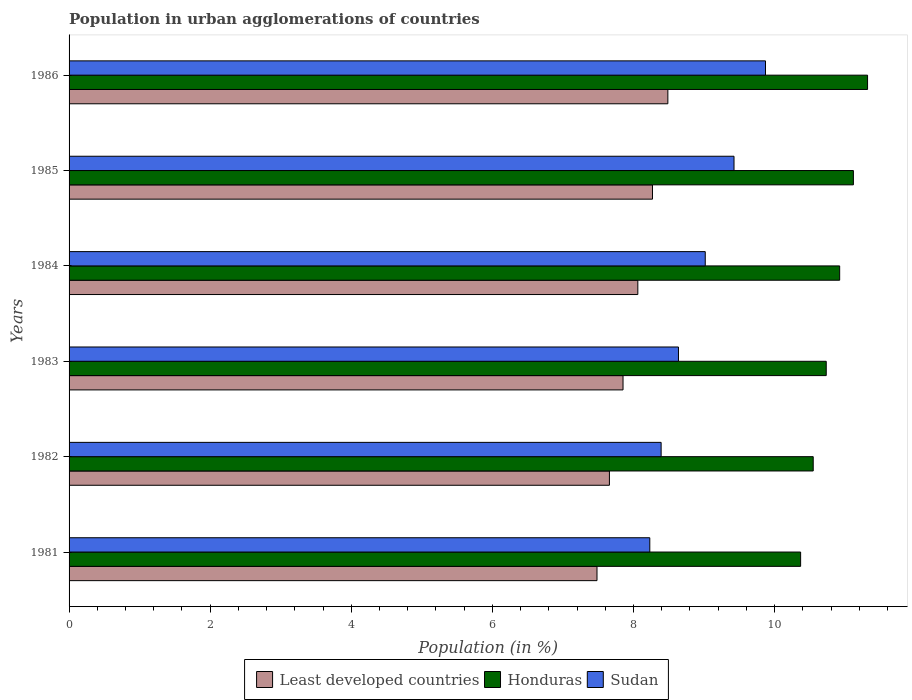How many groups of bars are there?
Offer a very short reply. 6. How many bars are there on the 5th tick from the top?
Provide a succinct answer. 3. In how many cases, is the number of bars for a given year not equal to the number of legend labels?
Your response must be concise. 0. What is the percentage of population in urban agglomerations in Least developed countries in 1982?
Your response must be concise. 7.66. Across all years, what is the maximum percentage of population in urban agglomerations in Honduras?
Ensure brevity in your answer.  11.32. Across all years, what is the minimum percentage of population in urban agglomerations in Sudan?
Your answer should be compact. 8.23. In which year was the percentage of population in urban agglomerations in Sudan maximum?
Give a very brief answer. 1986. In which year was the percentage of population in urban agglomerations in Least developed countries minimum?
Offer a very short reply. 1981. What is the total percentage of population in urban agglomerations in Honduras in the graph?
Keep it short and to the point. 65.01. What is the difference between the percentage of population in urban agglomerations in Least developed countries in 1982 and that in 1986?
Offer a very short reply. -0.83. What is the difference between the percentage of population in urban agglomerations in Sudan in 1981 and the percentage of population in urban agglomerations in Honduras in 1986?
Provide a short and direct response. -3.09. What is the average percentage of population in urban agglomerations in Least developed countries per year?
Make the answer very short. 7.97. In the year 1986, what is the difference between the percentage of population in urban agglomerations in Sudan and percentage of population in urban agglomerations in Honduras?
Keep it short and to the point. -1.45. In how many years, is the percentage of population in urban agglomerations in Least developed countries greater than 5.2 %?
Offer a very short reply. 6. What is the ratio of the percentage of population in urban agglomerations in Honduras in 1983 to that in 1984?
Keep it short and to the point. 0.98. Is the difference between the percentage of population in urban agglomerations in Sudan in 1985 and 1986 greater than the difference between the percentage of population in urban agglomerations in Honduras in 1985 and 1986?
Give a very brief answer. No. What is the difference between the highest and the second highest percentage of population in urban agglomerations in Honduras?
Provide a succinct answer. 0.2. What is the difference between the highest and the lowest percentage of population in urban agglomerations in Sudan?
Your answer should be compact. 1.64. In how many years, is the percentage of population in urban agglomerations in Honduras greater than the average percentage of population in urban agglomerations in Honduras taken over all years?
Provide a short and direct response. 3. What does the 1st bar from the top in 1982 represents?
Offer a very short reply. Sudan. What does the 3rd bar from the bottom in 1982 represents?
Keep it short and to the point. Sudan. Is it the case that in every year, the sum of the percentage of population in urban agglomerations in Sudan and percentage of population in urban agglomerations in Least developed countries is greater than the percentage of population in urban agglomerations in Honduras?
Offer a terse response. Yes. How many bars are there?
Ensure brevity in your answer.  18. Are the values on the major ticks of X-axis written in scientific E-notation?
Offer a terse response. No. Does the graph contain any zero values?
Give a very brief answer. No. Does the graph contain grids?
Your answer should be very brief. No. Where does the legend appear in the graph?
Your answer should be very brief. Bottom center. How are the legend labels stacked?
Keep it short and to the point. Horizontal. What is the title of the graph?
Your answer should be very brief. Population in urban agglomerations of countries. Does "Micronesia" appear as one of the legend labels in the graph?
Your response must be concise. No. What is the Population (in %) of Least developed countries in 1981?
Provide a succinct answer. 7.48. What is the Population (in %) in Honduras in 1981?
Offer a terse response. 10.37. What is the Population (in %) of Sudan in 1981?
Offer a very short reply. 8.23. What is the Population (in %) of Least developed countries in 1982?
Ensure brevity in your answer.  7.66. What is the Population (in %) of Honduras in 1982?
Your answer should be very brief. 10.55. What is the Population (in %) of Sudan in 1982?
Your answer should be very brief. 8.39. What is the Population (in %) of Least developed countries in 1983?
Ensure brevity in your answer.  7.85. What is the Population (in %) of Honduras in 1983?
Give a very brief answer. 10.73. What is the Population (in %) in Sudan in 1983?
Ensure brevity in your answer.  8.64. What is the Population (in %) of Least developed countries in 1984?
Your response must be concise. 8.06. What is the Population (in %) in Honduras in 1984?
Provide a short and direct response. 10.92. What is the Population (in %) in Sudan in 1984?
Ensure brevity in your answer.  9.02. What is the Population (in %) of Least developed countries in 1985?
Provide a succinct answer. 8.27. What is the Population (in %) of Honduras in 1985?
Make the answer very short. 11.12. What is the Population (in %) of Sudan in 1985?
Give a very brief answer. 9.42. What is the Population (in %) in Least developed countries in 1986?
Offer a very short reply. 8.49. What is the Population (in %) in Honduras in 1986?
Provide a succinct answer. 11.32. What is the Population (in %) in Sudan in 1986?
Make the answer very short. 9.87. Across all years, what is the maximum Population (in %) in Least developed countries?
Give a very brief answer. 8.49. Across all years, what is the maximum Population (in %) of Honduras?
Give a very brief answer. 11.32. Across all years, what is the maximum Population (in %) in Sudan?
Provide a succinct answer. 9.87. Across all years, what is the minimum Population (in %) in Least developed countries?
Your answer should be compact. 7.48. Across all years, what is the minimum Population (in %) of Honduras?
Provide a succinct answer. 10.37. Across all years, what is the minimum Population (in %) in Sudan?
Keep it short and to the point. 8.23. What is the total Population (in %) of Least developed countries in the graph?
Ensure brevity in your answer.  47.81. What is the total Population (in %) in Honduras in the graph?
Keep it short and to the point. 65.01. What is the total Population (in %) in Sudan in the graph?
Make the answer very short. 53.57. What is the difference between the Population (in %) in Least developed countries in 1981 and that in 1982?
Give a very brief answer. -0.18. What is the difference between the Population (in %) of Honduras in 1981 and that in 1982?
Your answer should be compact. -0.18. What is the difference between the Population (in %) in Sudan in 1981 and that in 1982?
Your response must be concise. -0.16. What is the difference between the Population (in %) in Least developed countries in 1981 and that in 1983?
Provide a short and direct response. -0.37. What is the difference between the Population (in %) in Honduras in 1981 and that in 1983?
Ensure brevity in your answer.  -0.36. What is the difference between the Population (in %) in Sudan in 1981 and that in 1983?
Ensure brevity in your answer.  -0.41. What is the difference between the Population (in %) in Least developed countries in 1981 and that in 1984?
Ensure brevity in your answer.  -0.58. What is the difference between the Population (in %) of Honduras in 1981 and that in 1984?
Provide a short and direct response. -0.55. What is the difference between the Population (in %) of Sudan in 1981 and that in 1984?
Ensure brevity in your answer.  -0.79. What is the difference between the Population (in %) in Least developed countries in 1981 and that in 1985?
Provide a succinct answer. -0.79. What is the difference between the Population (in %) of Honduras in 1981 and that in 1985?
Provide a short and direct response. -0.75. What is the difference between the Population (in %) of Sudan in 1981 and that in 1985?
Offer a terse response. -1.19. What is the difference between the Population (in %) in Least developed countries in 1981 and that in 1986?
Offer a terse response. -1. What is the difference between the Population (in %) in Honduras in 1981 and that in 1986?
Make the answer very short. -0.95. What is the difference between the Population (in %) of Sudan in 1981 and that in 1986?
Make the answer very short. -1.64. What is the difference between the Population (in %) of Least developed countries in 1982 and that in 1983?
Your answer should be compact. -0.19. What is the difference between the Population (in %) in Honduras in 1982 and that in 1983?
Give a very brief answer. -0.18. What is the difference between the Population (in %) in Sudan in 1982 and that in 1983?
Make the answer very short. -0.25. What is the difference between the Population (in %) of Least developed countries in 1982 and that in 1984?
Provide a succinct answer. -0.4. What is the difference between the Population (in %) in Honduras in 1982 and that in 1984?
Keep it short and to the point. -0.37. What is the difference between the Population (in %) in Sudan in 1982 and that in 1984?
Offer a terse response. -0.63. What is the difference between the Population (in %) of Least developed countries in 1982 and that in 1985?
Your answer should be compact. -0.61. What is the difference between the Population (in %) in Honduras in 1982 and that in 1985?
Make the answer very short. -0.57. What is the difference between the Population (in %) of Sudan in 1982 and that in 1985?
Provide a succinct answer. -1.03. What is the difference between the Population (in %) of Least developed countries in 1982 and that in 1986?
Provide a short and direct response. -0.83. What is the difference between the Population (in %) of Honduras in 1982 and that in 1986?
Make the answer very short. -0.77. What is the difference between the Population (in %) of Sudan in 1982 and that in 1986?
Ensure brevity in your answer.  -1.48. What is the difference between the Population (in %) in Least developed countries in 1983 and that in 1984?
Offer a terse response. -0.21. What is the difference between the Population (in %) of Honduras in 1983 and that in 1984?
Your response must be concise. -0.19. What is the difference between the Population (in %) of Sudan in 1983 and that in 1984?
Give a very brief answer. -0.38. What is the difference between the Population (in %) of Least developed countries in 1983 and that in 1985?
Give a very brief answer. -0.42. What is the difference between the Population (in %) in Honduras in 1983 and that in 1985?
Ensure brevity in your answer.  -0.38. What is the difference between the Population (in %) of Sudan in 1983 and that in 1985?
Ensure brevity in your answer.  -0.79. What is the difference between the Population (in %) in Least developed countries in 1983 and that in 1986?
Provide a short and direct response. -0.64. What is the difference between the Population (in %) of Honduras in 1983 and that in 1986?
Provide a short and direct response. -0.59. What is the difference between the Population (in %) in Sudan in 1983 and that in 1986?
Your answer should be compact. -1.23. What is the difference between the Population (in %) of Least developed countries in 1984 and that in 1985?
Your answer should be very brief. -0.21. What is the difference between the Population (in %) in Honduras in 1984 and that in 1985?
Give a very brief answer. -0.19. What is the difference between the Population (in %) in Sudan in 1984 and that in 1985?
Provide a succinct answer. -0.41. What is the difference between the Population (in %) of Least developed countries in 1984 and that in 1986?
Your answer should be very brief. -0.43. What is the difference between the Population (in %) of Honduras in 1984 and that in 1986?
Make the answer very short. -0.4. What is the difference between the Population (in %) of Sudan in 1984 and that in 1986?
Offer a terse response. -0.85. What is the difference between the Population (in %) of Least developed countries in 1985 and that in 1986?
Ensure brevity in your answer.  -0.22. What is the difference between the Population (in %) in Honduras in 1985 and that in 1986?
Offer a very short reply. -0.2. What is the difference between the Population (in %) in Sudan in 1985 and that in 1986?
Make the answer very short. -0.45. What is the difference between the Population (in %) in Least developed countries in 1981 and the Population (in %) in Honduras in 1982?
Provide a short and direct response. -3.06. What is the difference between the Population (in %) of Least developed countries in 1981 and the Population (in %) of Sudan in 1982?
Your response must be concise. -0.91. What is the difference between the Population (in %) in Honduras in 1981 and the Population (in %) in Sudan in 1982?
Give a very brief answer. 1.98. What is the difference between the Population (in %) of Least developed countries in 1981 and the Population (in %) of Honduras in 1983?
Provide a short and direct response. -3.25. What is the difference between the Population (in %) of Least developed countries in 1981 and the Population (in %) of Sudan in 1983?
Provide a succinct answer. -1.15. What is the difference between the Population (in %) in Honduras in 1981 and the Population (in %) in Sudan in 1983?
Give a very brief answer. 1.73. What is the difference between the Population (in %) of Least developed countries in 1981 and the Population (in %) of Honduras in 1984?
Your answer should be compact. -3.44. What is the difference between the Population (in %) in Least developed countries in 1981 and the Population (in %) in Sudan in 1984?
Make the answer very short. -1.53. What is the difference between the Population (in %) of Honduras in 1981 and the Population (in %) of Sudan in 1984?
Ensure brevity in your answer.  1.35. What is the difference between the Population (in %) in Least developed countries in 1981 and the Population (in %) in Honduras in 1985?
Ensure brevity in your answer.  -3.63. What is the difference between the Population (in %) of Least developed countries in 1981 and the Population (in %) of Sudan in 1985?
Offer a very short reply. -1.94. What is the difference between the Population (in %) of Honduras in 1981 and the Population (in %) of Sudan in 1985?
Provide a short and direct response. 0.94. What is the difference between the Population (in %) in Least developed countries in 1981 and the Population (in %) in Honduras in 1986?
Provide a short and direct response. -3.84. What is the difference between the Population (in %) in Least developed countries in 1981 and the Population (in %) in Sudan in 1986?
Provide a short and direct response. -2.39. What is the difference between the Population (in %) in Honduras in 1981 and the Population (in %) in Sudan in 1986?
Make the answer very short. 0.5. What is the difference between the Population (in %) in Least developed countries in 1982 and the Population (in %) in Honduras in 1983?
Keep it short and to the point. -3.07. What is the difference between the Population (in %) in Least developed countries in 1982 and the Population (in %) in Sudan in 1983?
Keep it short and to the point. -0.98. What is the difference between the Population (in %) of Honduras in 1982 and the Population (in %) of Sudan in 1983?
Provide a short and direct response. 1.91. What is the difference between the Population (in %) in Least developed countries in 1982 and the Population (in %) in Honduras in 1984?
Keep it short and to the point. -3.26. What is the difference between the Population (in %) in Least developed countries in 1982 and the Population (in %) in Sudan in 1984?
Your answer should be very brief. -1.36. What is the difference between the Population (in %) of Honduras in 1982 and the Population (in %) of Sudan in 1984?
Provide a succinct answer. 1.53. What is the difference between the Population (in %) in Least developed countries in 1982 and the Population (in %) in Honduras in 1985?
Your answer should be very brief. -3.46. What is the difference between the Population (in %) in Least developed countries in 1982 and the Population (in %) in Sudan in 1985?
Offer a terse response. -1.77. What is the difference between the Population (in %) in Honduras in 1982 and the Population (in %) in Sudan in 1985?
Your answer should be very brief. 1.12. What is the difference between the Population (in %) of Least developed countries in 1982 and the Population (in %) of Honduras in 1986?
Provide a succinct answer. -3.66. What is the difference between the Population (in %) in Least developed countries in 1982 and the Population (in %) in Sudan in 1986?
Keep it short and to the point. -2.21. What is the difference between the Population (in %) in Honduras in 1982 and the Population (in %) in Sudan in 1986?
Ensure brevity in your answer.  0.68. What is the difference between the Population (in %) in Least developed countries in 1983 and the Population (in %) in Honduras in 1984?
Keep it short and to the point. -3.07. What is the difference between the Population (in %) of Least developed countries in 1983 and the Population (in %) of Sudan in 1984?
Your response must be concise. -1.17. What is the difference between the Population (in %) in Honduras in 1983 and the Population (in %) in Sudan in 1984?
Make the answer very short. 1.71. What is the difference between the Population (in %) in Least developed countries in 1983 and the Population (in %) in Honduras in 1985?
Offer a very short reply. -3.27. What is the difference between the Population (in %) of Least developed countries in 1983 and the Population (in %) of Sudan in 1985?
Give a very brief answer. -1.57. What is the difference between the Population (in %) in Honduras in 1983 and the Population (in %) in Sudan in 1985?
Provide a succinct answer. 1.31. What is the difference between the Population (in %) of Least developed countries in 1983 and the Population (in %) of Honduras in 1986?
Your answer should be compact. -3.47. What is the difference between the Population (in %) of Least developed countries in 1983 and the Population (in %) of Sudan in 1986?
Your response must be concise. -2.02. What is the difference between the Population (in %) in Honduras in 1983 and the Population (in %) in Sudan in 1986?
Keep it short and to the point. 0.86. What is the difference between the Population (in %) of Least developed countries in 1984 and the Population (in %) of Honduras in 1985?
Provide a succinct answer. -3.06. What is the difference between the Population (in %) of Least developed countries in 1984 and the Population (in %) of Sudan in 1985?
Make the answer very short. -1.36. What is the difference between the Population (in %) of Honduras in 1984 and the Population (in %) of Sudan in 1985?
Ensure brevity in your answer.  1.5. What is the difference between the Population (in %) of Least developed countries in 1984 and the Population (in %) of Honduras in 1986?
Give a very brief answer. -3.26. What is the difference between the Population (in %) of Least developed countries in 1984 and the Population (in %) of Sudan in 1986?
Ensure brevity in your answer.  -1.81. What is the difference between the Population (in %) of Honduras in 1984 and the Population (in %) of Sudan in 1986?
Your answer should be compact. 1.05. What is the difference between the Population (in %) in Least developed countries in 1985 and the Population (in %) in Honduras in 1986?
Your response must be concise. -3.05. What is the difference between the Population (in %) in Least developed countries in 1985 and the Population (in %) in Sudan in 1986?
Your answer should be very brief. -1.6. What is the difference between the Population (in %) of Honduras in 1985 and the Population (in %) of Sudan in 1986?
Provide a short and direct response. 1.25. What is the average Population (in %) of Least developed countries per year?
Your answer should be very brief. 7.97. What is the average Population (in %) of Honduras per year?
Offer a terse response. 10.83. What is the average Population (in %) of Sudan per year?
Provide a short and direct response. 8.93. In the year 1981, what is the difference between the Population (in %) in Least developed countries and Population (in %) in Honduras?
Provide a succinct answer. -2.89. In the year 1981, what is the difference between the Population (in %) of Least developed countries and Population (in %) of Sudan?
Make the answer very short. -0.75. In the year 1981, what is the difference between the Population (in %) of Honduras and Population (in %) of Sudan?
Make the answer very short. 2.14. In the year 1982, what is the difference between the Population (in %) in Least developed countries and Population (in %) in Honduras?
Offer a terse response. -2.89. In the year 1982, what is the difference between the Population (in %) of Least developed countries and Population (in %) of Sudan?
Offer a terse response. -0.73. In the year 1982, what is the difference between the Population (in %) of Honduras and Population (in %) of Sudan?
Provide a short and direct response. 2.16. In the year 1983, what is the difference between the Population (in %) in Least developed countries and Population (in %) in Honduras?
Ensure brevity in your answer.  -2.88. In the year 1983, what is the difference between the Population (in %) of Least developed countries and Population (in %) of Sudan?
Your answer should be compact. -0.79. In the year 1983, what is the difference between the Population (in %) of Honduras and Population (in %) of Sudan?
Make the answer very short. 2.09. In the year 1984, what is the difference between the Population (in %) of Least developed countries and Population (in %) of Honduras?
Give a very brief answer. -2.86. In the year 1984, what is the difference between the Population (in %) in Least developed countries and Population (in %) in Sudan?
Provide a short and direct response. -0.96. In the year 1984, what is the difference between the Population (in %) of Honduras and Population (in %) of Sudan?
Ensure brevity in your answer.  1.91. In the year 1985, what is the difference between the Population (in %) of Least developed countries and Population (in %) of Honduras?
Give a very brief answer. -2.85. In the year 1985, what is the difference between the Population (in %) in Least developed countries and Population (in %) in Sudan?
Give a very brief answer. -1.16. In the year 1985, what is the difference between the Population (in %) of Honduras and Population (in %) of Sudan?
Ensure brevity in your answer.  1.69. In the year 1986, what is the difference between the Population (in %) of Least developed countries and Population (in %) of Honduras?
Offer a terse response. -2.83. In the year 1986, what is the difference between the Population (in %) of Least developed countries and Population (in %) of Sudan?
Provide a short and direct response. -1.38. In the year 1986, what is the difference between the Population (in %) of Honduras and Population (in %) of Sudan?
Your answer should be very brief. 1.45. What is the ratio of the Population (in %) of Honduras in 1981 to that in 1982?
Ensure brevity in your answer.  0.98. What is the ratio of the Population (in %) of Sudan in 1981 to that in 1982?
Provide a succinct answer. 0.98. What is the ratio of the Population (in %) in Least developed countries in 1981 to that in 1983?
Your answer should be compact. 0.95. What is the ratio of the Population (in %) of Honduras in 1981 to that in 1983?
Give a very brief answer. 0.97. What is the ratio of the Population (in %) in Sudan in 1981 to that in 1983?
Your answer should be compact. 0.95. What is the ratio of the Population (in %) in Least developed countries in 1981 to that in 1984?
Your answer should be very brief. 0.93. What is the ratio of the Population (in %) of Honduras in 1981 to that in 1984?
Provide a succinct answer. 0.95. What is the ratio of the Population (in %) of Sudan in 1981 to that in 1984?
Offer a terse response. 0.91. What is the ratio of the Population (in %) of Least developed countries in 1981 to that in 1985?
Give a very brief answer. 0.9. What is the ratio of the Population (in %) of Honduras in 1981 to that in 1985?
Ensure brevity in your answer.  0.93. What is the ratio of the Population (in %) of Sudan in 1981 to that in 1985?
Your response must be concise. 0.87. What is the ratio of the Population (in %) in Least developed countries in 1981 to that in 1986?
Ensure brevity in your answer.  0.88. What is the ratio of the Population (in %) of Honduras in 1981 to that in 1986?
Offer a very short reply. 0.92. What is the ratio of the Population (in %) of Sudan in 1981 to that in 1986?
Offer a very short reply. 0.83. What is the ratio of the Population (in %) of Least developed countries in 1982 to that in 1983?
Keep it short and to the point. 0.98. What is the ratio of the Population (in %) of Honduras in 1982 to that in 1983?
Your answer should be compact. 0.98. What is the ratio of the Population (in %) of Sudan in 1982 to that in 1983?
Ensure brevity in your answer.  0.97. What is the ratio of the Population (in %) in Least developed countries in 1982 to that in 1984?
Offer a very short reply. 0.95. What is the ratio of the Population (in %) in Honduras in 1982 to that in 1984?
Your response must be concise. 0.97. What is the ratio of the Population (in %) of Sudan in 1982 to that in 1984?
Your answer should be compact. 0.93. What is the ratio of the Population (in %) in Least developed countries in 1982 to that in 1985?
Provide a succinct answer. 0.93. What is the ratio of the Population (in %) of Honduras in 1982 to that in 1985?
Make the answer very short. 0.95. What is the ratio of the Population (in %) in Sudan in 1982 to that in 1985?
Make the answer very short. 0.89. What is the ratio of the Population (in %) of Least developed countries in 1982 to that in 1986?
Provide a short and direct response. 0.9. What is the ratio of the Population (in %) in Honduras in 1982 to that in 1986?
Give a very brief answer. 0.93. What is the ratio of the Population (in %) in Sudan in 1982 to that in 1986?
Provide a succinct answer. 0.85. What is the ratio of the Population (in %) of Least developed countries in 1983 to that in 1984?
Ensure brevity in your answer.  0.97. What is the ratio of the Population (in %) of Honduras in 1983 to that in 1984?
Give a very brief answer. 0.98. What is the ratio of the Population (in %) of Sudan in 1983 to that in 1984?
Offer a terse response. 0.96. What is the ratio of the Population (in %) in Least developed countries in 1983 to that in 1985?
Ensure brevity in your answer.  0.95. What is the ratio of the Population (in %) of Honduras in 1983 to that in 1985?
Offer a terse response. 0.97. What is the ratio of the Population (in %) of Sudan in 1983 to that in 1985?
Provide a short and direct response. 0.92. What is the ratio of the Population (in %) of Least developed countries in 1983 to that in 1986?
Keep it short and to the point. 0.93. What is the ratio of the Population (in %) of Honduras in 1983 to that in 1986?
Offer a very short reply. 0.95. What is the ratio of the Population (in %) in Least developed countries in 1984 to that in 1985?
Make the answer very short. 0.97. What is the ratio of the Population (in %) in Honduras in 1984 to that in 1985?
Give a very brief answer. 0.98. What is the ratio of the Population (in %) of Sudan in 1984 to that in 1985?
Ensure brevity in your answer.  0.96. What is the ratio of the Population (in %) in Least developed countries in 1984 to that in 1986?
Make the answer very short. 0.95. What is the ratio of the Population (in %) of Honduras in 1984 to that in 1986?
Offer a very short reply. 0.97. What is the ratio of the Population (in %) in Sudan in 1984 to that in 1986?
Your answer should be compact. 0.91. What is the ratio of the Population (in %) of Least developed countries in 1985 to that in 1986?
Offer a terse response. 0.97. What is the ratio of the Population (in %) of Honduras in 1985 to that in 1986?
Your answer should be compact. 0.98. What is the ratio of the Population (in %) of Sudan in 1985 to that in 1986?
Offer a very short reply. 0.95. What is the difference between the highest and the second highest Population (in %) of Least developed countries?
Offer a terse response. 0.22. What is the difference between the highest and the second highest Population (in %) of Honduras?
Your answer should be compact. 0.2. What is the difference between the highest and the second highest Population (in %) in Sudan?
Your answer should be compact. 0.45. What is the difference between the highest and the lowest Population (in %) in Least developed countries?
Offer a very short reply. 1. What is the difference between the highest and the lowest Population (in %) in Honduras?
Your answer should be compact. 0.95. What is the difference between the highest and the lowest Population (in %) in Sudan?
Ensure brevity in your answer.  1.64. 